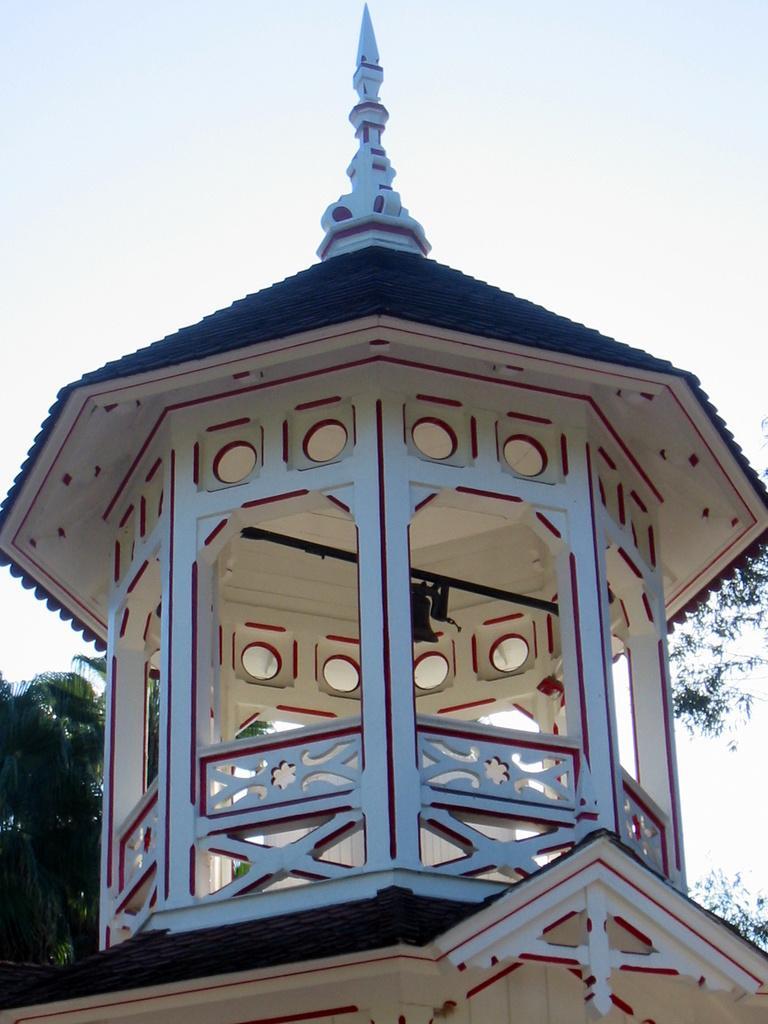Describe this image in one or two sentences. In this image we can see a house, there is a bell, we can also see some trees, and the sky. 